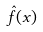Convert formula to latex. <formula><loc_0><loc_0><loc_500><loc_500>\hat { f } ( x )</formula> 